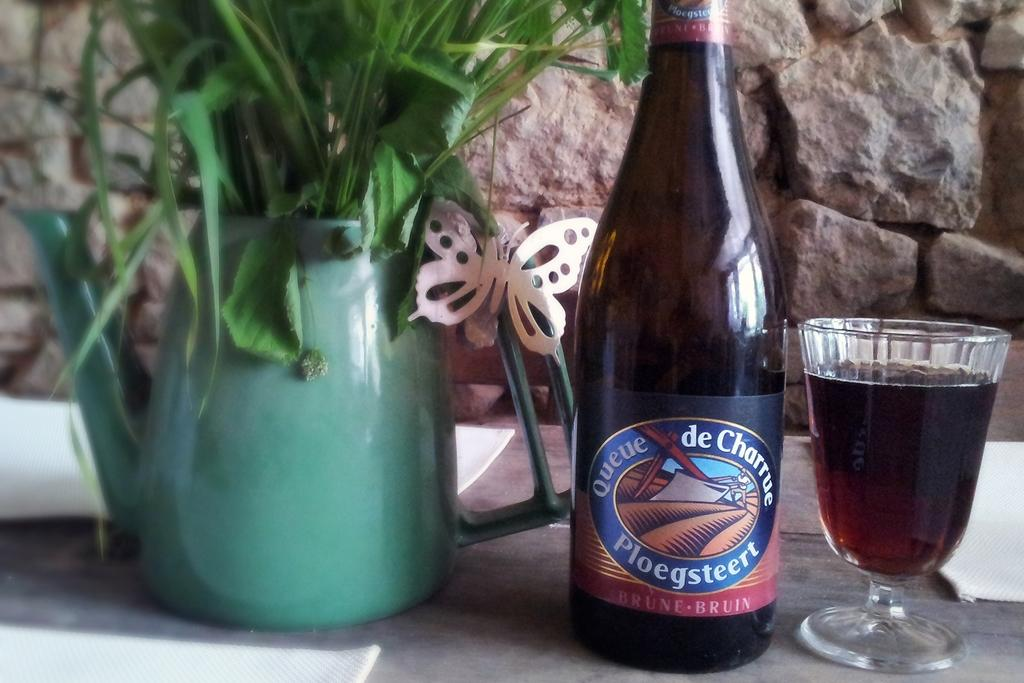Provide a one-sentence caption for the provided image. Ploegsteert beer bottle in between a plant and a cup of beer. 